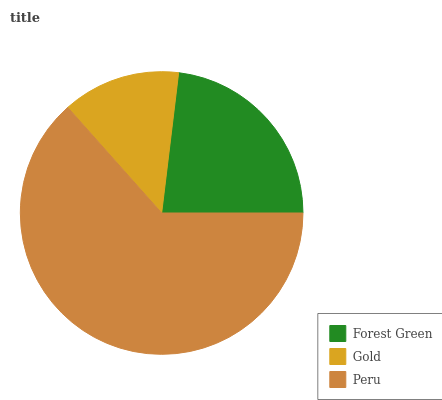Is Gold the minimum?
Answer yes or no. Yes. Is Peru the maximum?
Answer yes or no. Yes. Is Peru the minimum?
Answer yes or no. No. Is Gold the maximum?
Answer yes or no. No. Is Peru greater than Gold?
Answer yes or no. Yes. Is Gold less than Peru?
Answer yes or no. Yes. Is Gold greater than Peru?
Answer yes or no. No. Is Peru less than Gold?
Answer yes or no. No. Is Forest Green the high median?
Answer yes or no. Yes. Is Forest Green the low median?
Answer yes or no. Yes. Is Gold the high median?
Answer yes or no. No. Is Gold the low median?
Answer yes or no. No. 